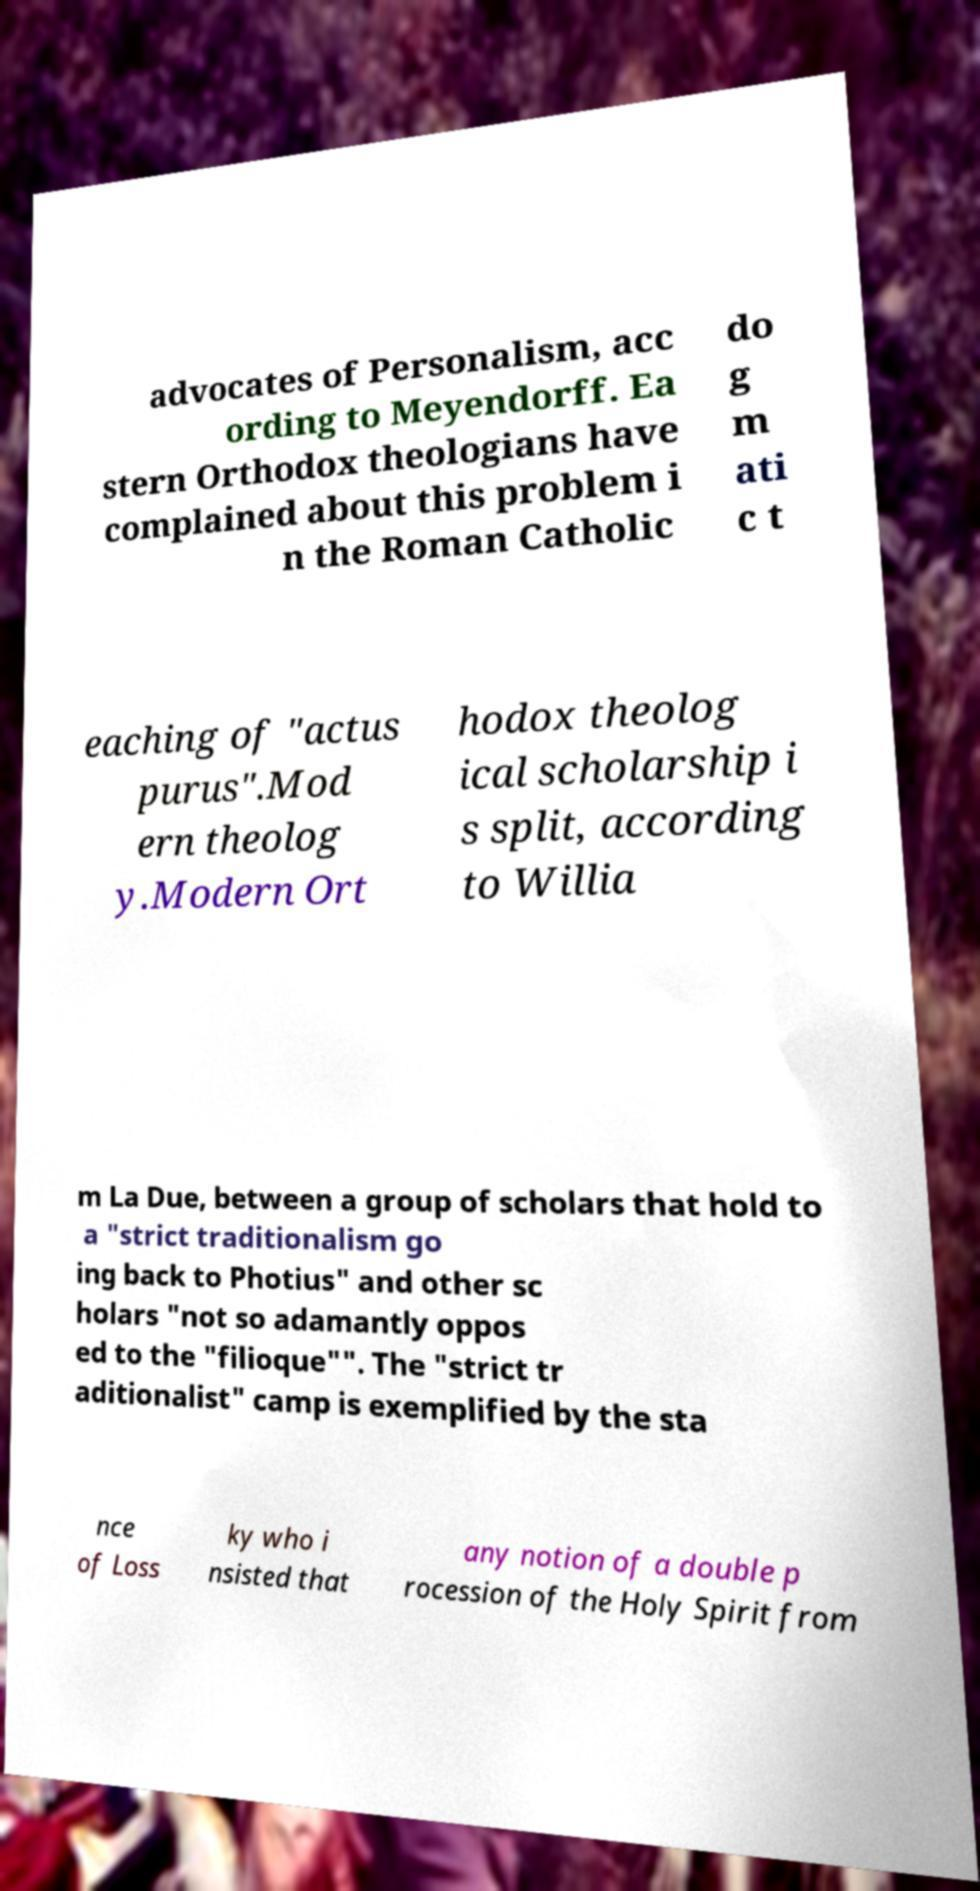Please read and relay the text visible in this image. What does it say? advocates of Personalism, acc ording to Meyendorff. Ea stern Orthodox theologians have complained about this problem i n the Roman Catholic do g m ati c t eaching of "actus purus".Mod ern theolog y.Modern Ort hodox theolog ical scholarship i s split, according to Willia m La Due, between a group of scholars that hold to a "strict traditionalism go ing back to Photius" and other sc holars "not so adamantly oppos ed to the "filioque"". The "strict tr aditionalist" camp is exemplified by the sta nce of Loss ky who i nsisted that any notion of a double p rocession of the Holy Spirit from 